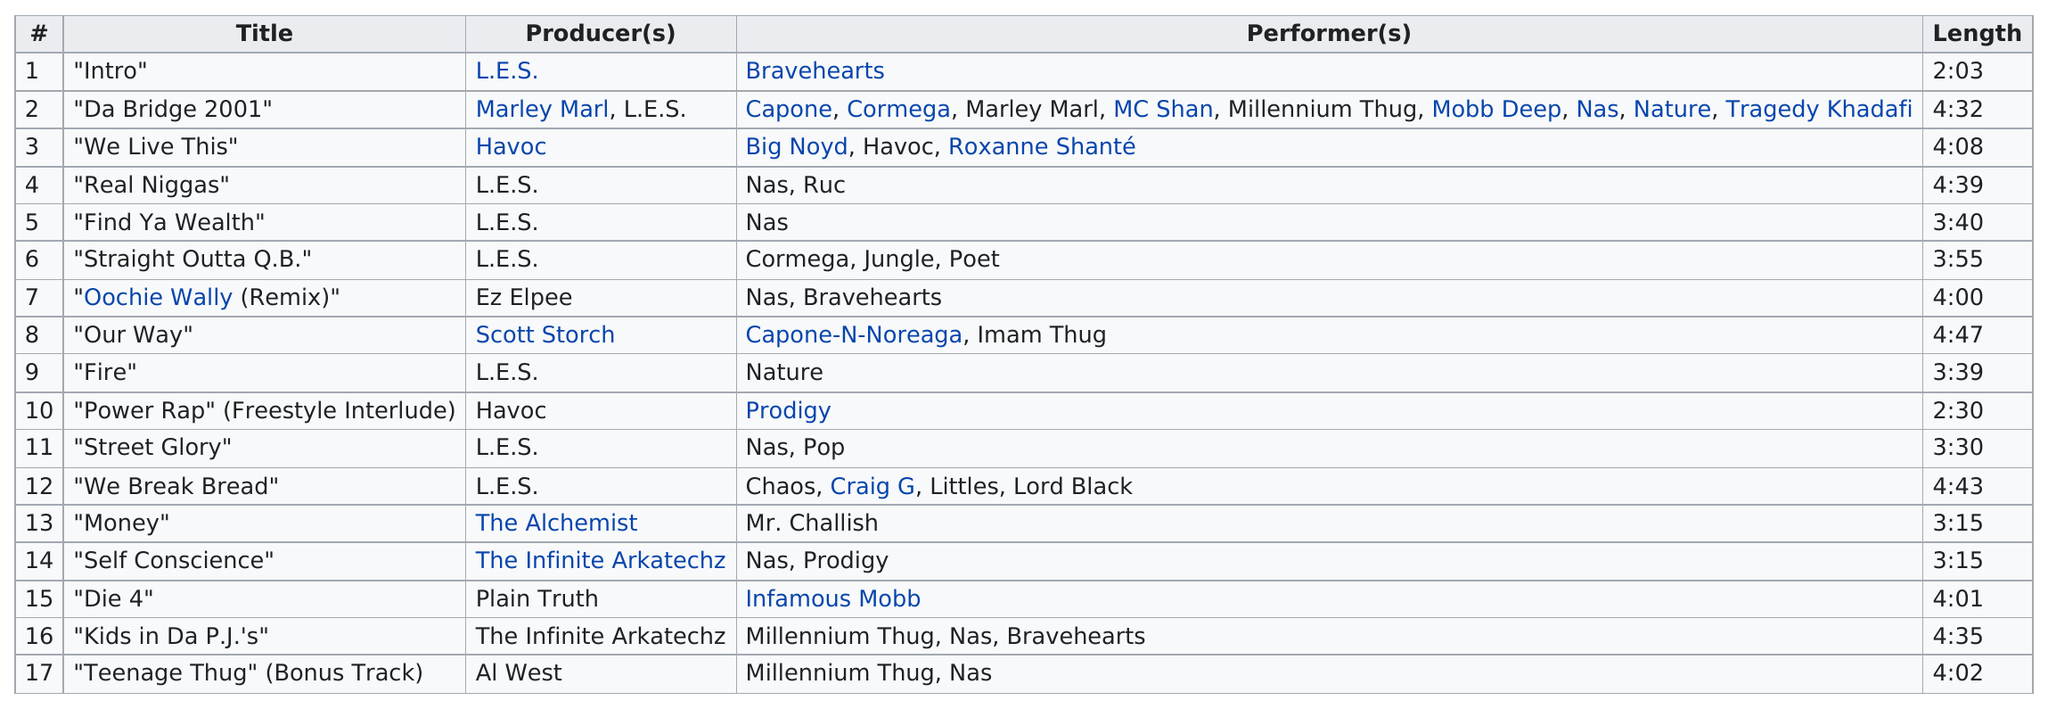Identify some key points in this picture. The track list consisted of 17 songs. The last track of the album was produced by Al West. I believe 'Die 4' is longer than 'Fire.' There are at least 9 songs that are at least 4 minutes long. The first song on the album produced by Havoc is titled 'We Live This'. 